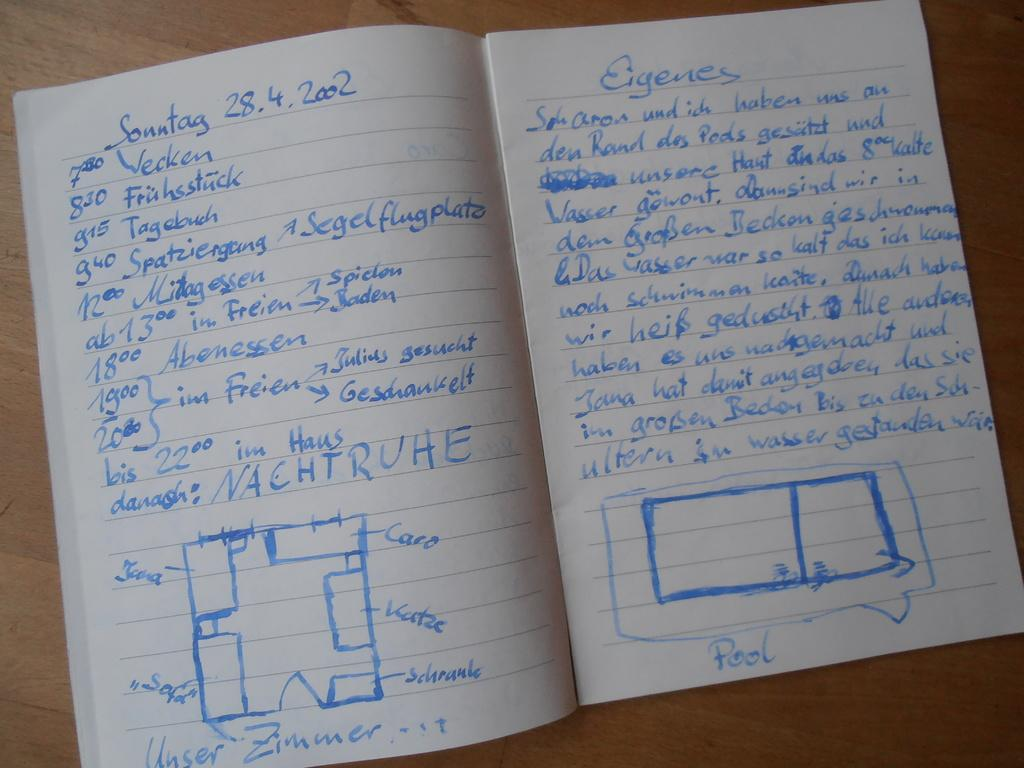<image>
Offer a succinct explanation of the picture presented. An open journal with diagrams and various notations and times written in German. 